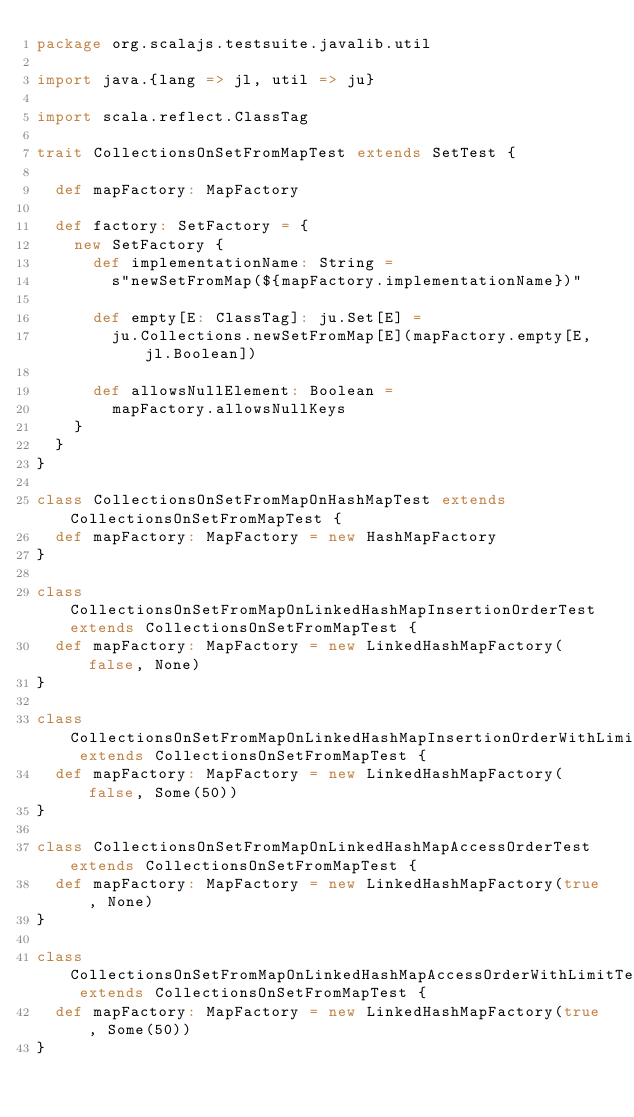Convert code to text. <code><loc_0><loc_0><loc_500><loc_500><_Scala_>package org.scalajs.testsuite.javalib.util

import java.{lang => jl, util => ju}

import scala.reflect.ClassTag

trait CollectionsOnSetFromMapTest extends SetTest {

  def mapFactory: MapFactory

  def factory: SetFactory = {
    new SetFactory {
      def implementationName: String =
        s"newSetFromMap(${mapFactory.implementationName})"

      def empty[E: ClassTag]: ju.Set[E] =
        ju.Collections.newSetFromMap[E](mapFactory.empty[E, jl.Boolean])

      def allowsNullElement: Boolean =
        mapFactory.allowsNullKeys
    }
  }
}

class CollectionsOnSetFromMapOnHashMapTest extends CollectionsOnSetFromMapTest {
  def mapFactory: MapFactory = new HashMapFactory
}

class CollectionsOnSetFromMapOnLinkedHashMapInsertionOrderTest extends CollectionsOnSetFromMapTest {
  def mapFactory: MapFactory = new LinkedHashMapFactory(false, None)
}

class CollectionsOnSetFromMapOnLinkedHashMapInsertionOrderWithLimitTest extends CollectionsOnSetFromMapTest {
  def mapFactory: MapFactory = new LinkedHashMapFactory(false, Some(50))
}

class CollectionsOnSetFromMapOnLinkedHashMapAccessOrderTest extends CollectionsOnSetFromMapTest {
  def mapFactory: MapFactory = new LinkedHashMapFactory(true, None)
}

class CollectionsOnSetFromMapOnLinkedHashMapAccessOrderWithLimitTest extends CollectionsOnSetFromMapTest {
  def mapFactory: MapFactory = new LinkedHashMapFactory(true, Some(50))
}
</code> 